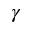<formula> <loc_0><loc_0><loc_500><loc_500>\gamma</formula> 